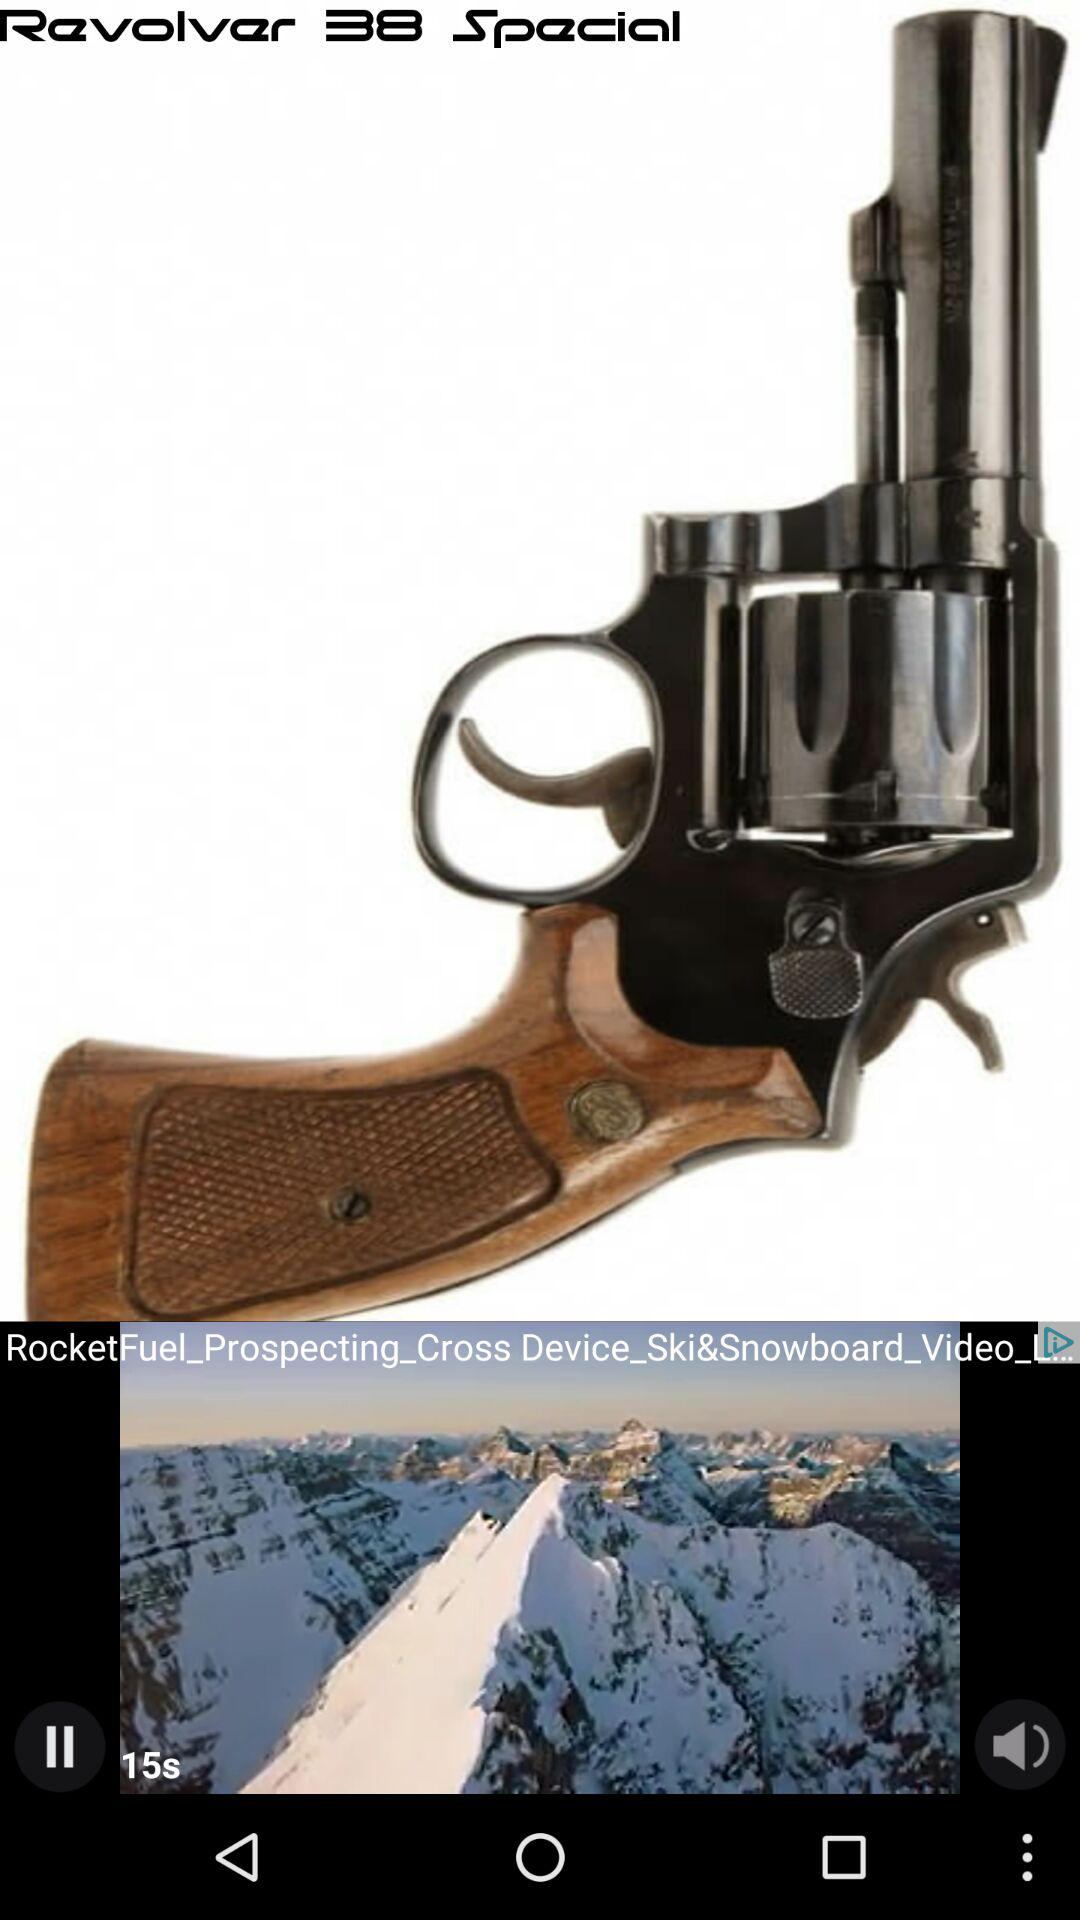What is the time duration of the video? The time duration of the video is 15 seconds. 